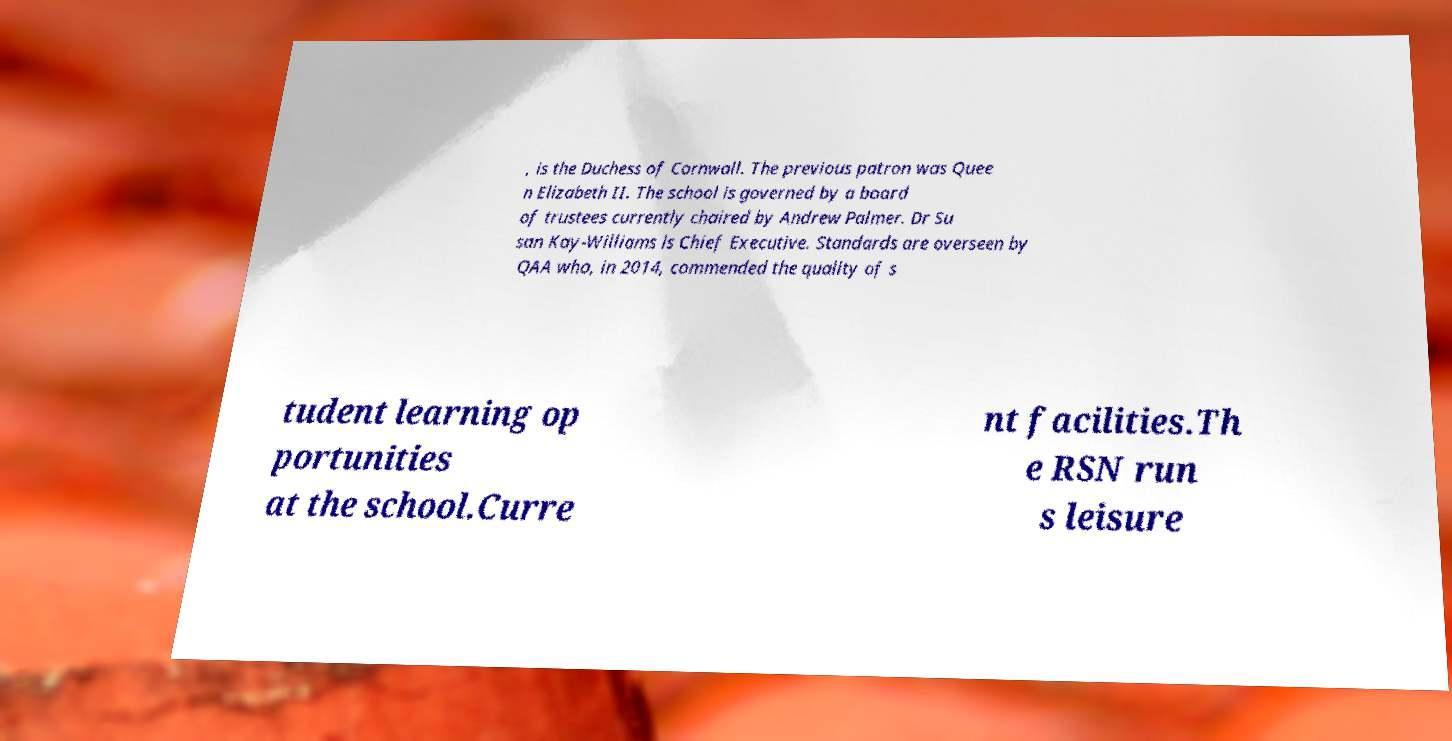Please identify and transcribe the text found in this image. , is the Duchess of Cornwall. The previous patron was Quee n Elizabeth II. The school is governed by a board of trustees currently chaired by Andrew Palmer. Dr Su san Kay-Williams is Chief Executive. Standards are overseen by QAA who, in 2014, commended the quality of s tudent learning op portunities at the school.Curre nt facilities.Th e RSN run s leisure 